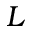Convert formula to latex. <formula><loc_0><loc_0><loc_500><loc_500>L</formula> 